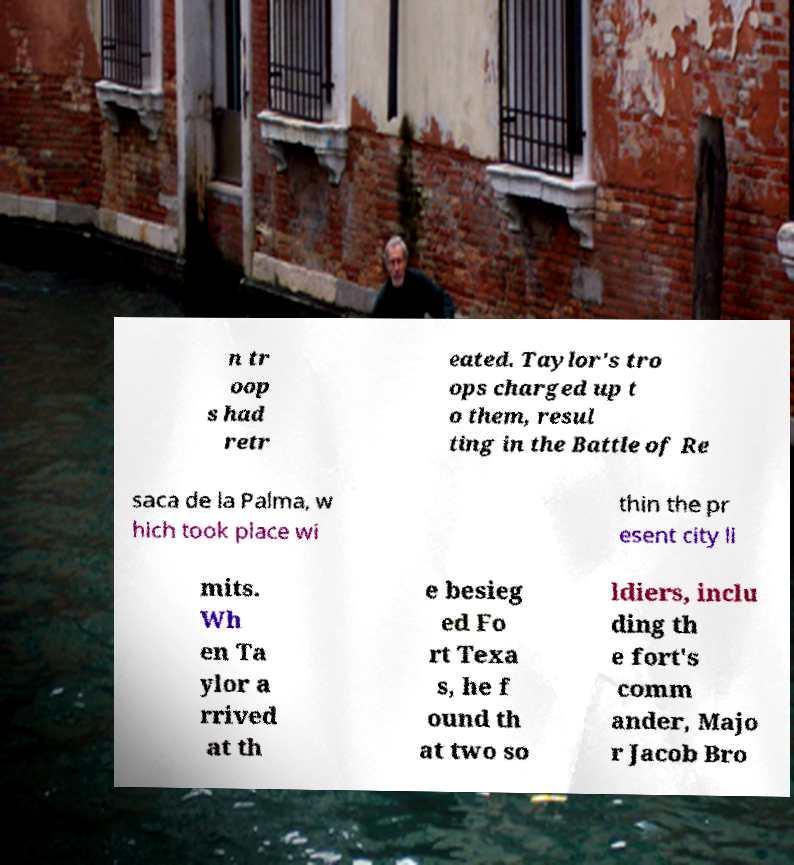Can you read and provide the text displayed in the image?This photo seems to have some interesting text. Can you extract and type it out for me? n tr oop s had retr eated. Taylor's tro ops charged up t o them, resul ting in the Battle of Re saca de la Palma, w hich took place wi thin the pr esent city li mits. Wh en Ta ylor a rrived at th e besieg ed Fo rt Texa s, he f ound th at two so ldiers, inclu ding th e fort's comm ander, Majo r Jacob Bro 